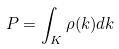Convert formula to latex. <formula><loc_0><loc_0><loc_500><loc_500>P = \int _ { K } \rho ( k ) d k</formula> 